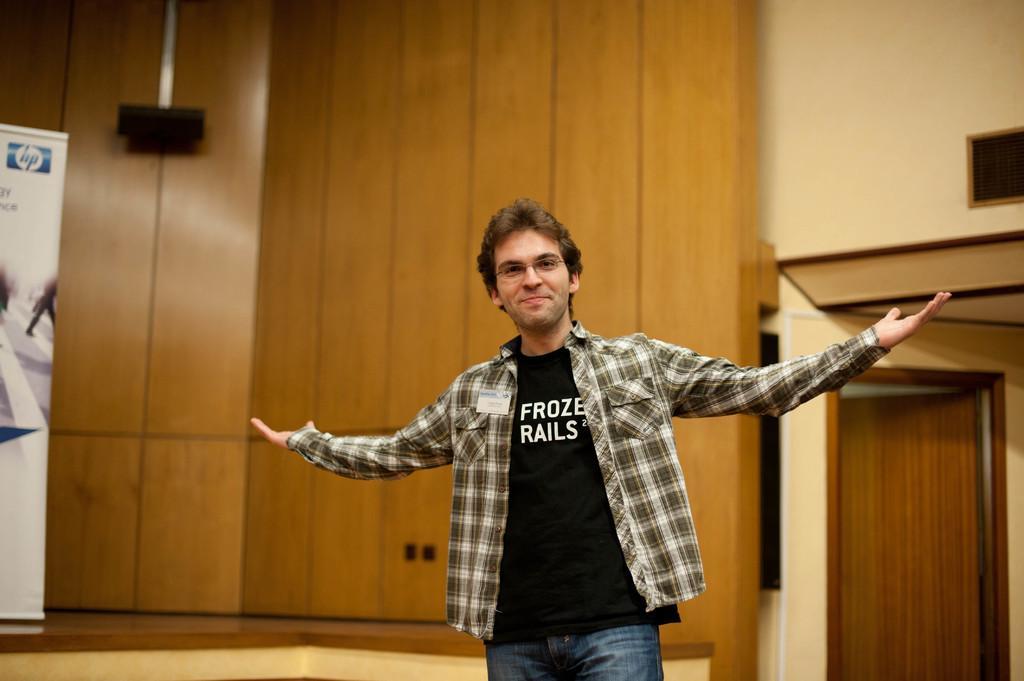Can you describe this image briefly? There is a man standing and smiling. In the background we can door, wall, object and banner. 